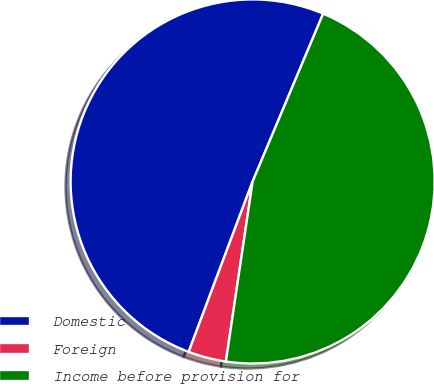<chart> <loc_0><loc_0><loc_500><loc_500><pie_chart><fcel>Domestic<fcel>Foreign<fcel>Income before provision for<nl><fcel>50.62%<fcel>3.37%<fcel>46.02%<nl></chart> 